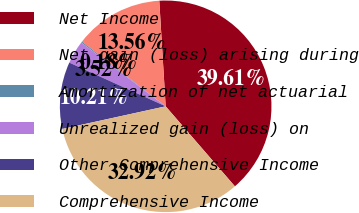<chart> <loc_0><loc_0><loc_500><loc_500><pie_chart><fcel>Net Income<fcel>Net gain (loss) arising during<fcel>Amortization of net actuarial<fcel>Unrealized gain (loss) on<fcel>Other Comprehensive Income<fcel>Comprehensive Income<nl><fcel>39.61%<fcel>13.56%<fcel>0.18%<fcel>3.52%<fcel>10.21%<fcel>32.92%<nl></chart> 